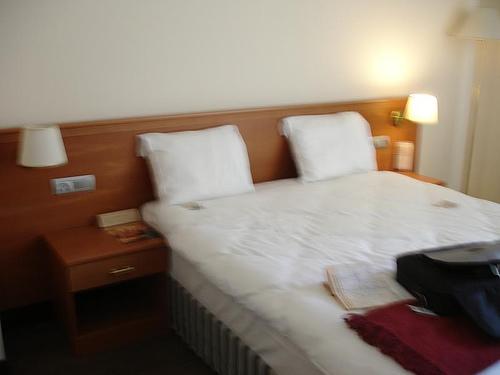How many lamps are turned on?
Quick response, please. 1. Is something on the wall that doesn't belong?
Give a very brief answer. No. What are the things on the bed?
Quick response, please. Pillows. What room is there?
Answer briefly. Bedroom. Is this a hotel?
Concise answer only. Yes. Where is the thermostat?
Keep it brief. Wall. How many sets of towels on the bed?
Keep it brief. 1. Is the bed neat?
Keep it brief. Yes. How many people should fit in this bed size?
Be succinct. 2. How many pillows are there?
Give a very brief answer. 2. What color is the pillow monogram?
Quick response, please. White. From where is the light emanating?
Give a very brief answer. Lamp. What color are the pillows in front?
Concise answer only. White. 